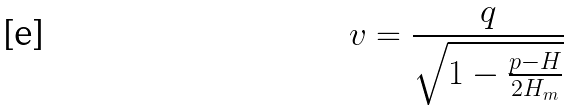<formula> <loc_0><loc_0><loc_500><loc_500>v = \frac { q } { \sqrt { 1 - \frac { p - H } { 2 H _ { m } } } }</formula> 